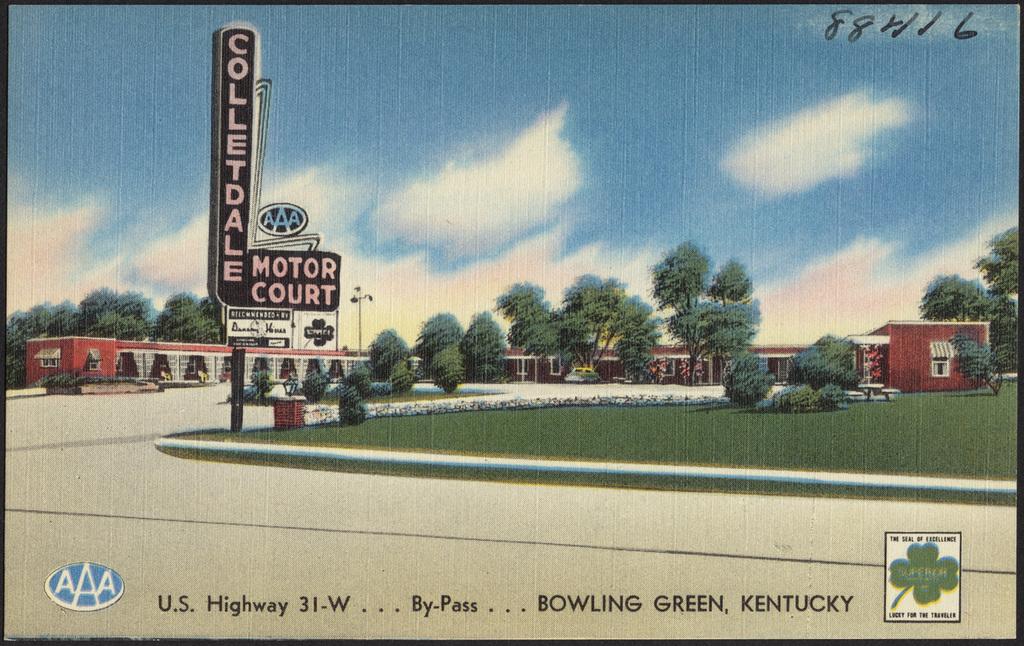What large numbers are on this sign?
Ensure brevity in your answer.  88416. Which u.s. highway is referenced?
Give a very brief answer. 31-w. 